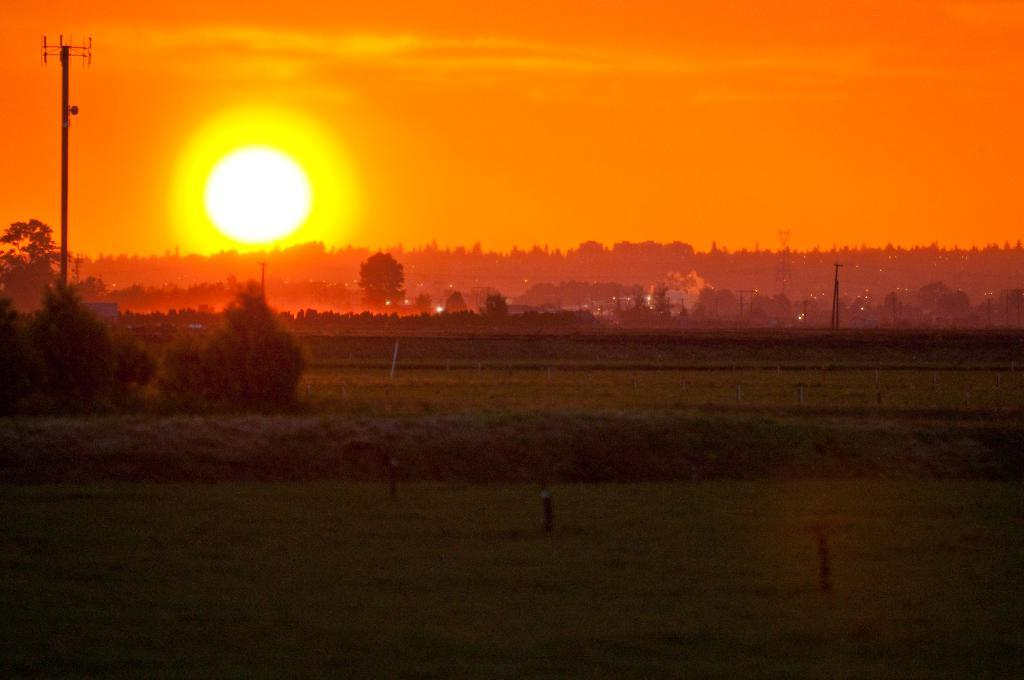What type of natural elements are present in the image? There are trees and plants in the image. What object can be seen on the left side of the image? There is a pole on the left side of the image. What celestial body is visible in the sky in the background of the image? The sun is visible in the sky in the background of the image. What type of silk is being produced by the industry in the image? There is no industry or silk production present in the image; it features trees, plants, and a pole. Can you describe the battle taking place in the image? There is no battle present in the image; it features natural elements and a pole. 